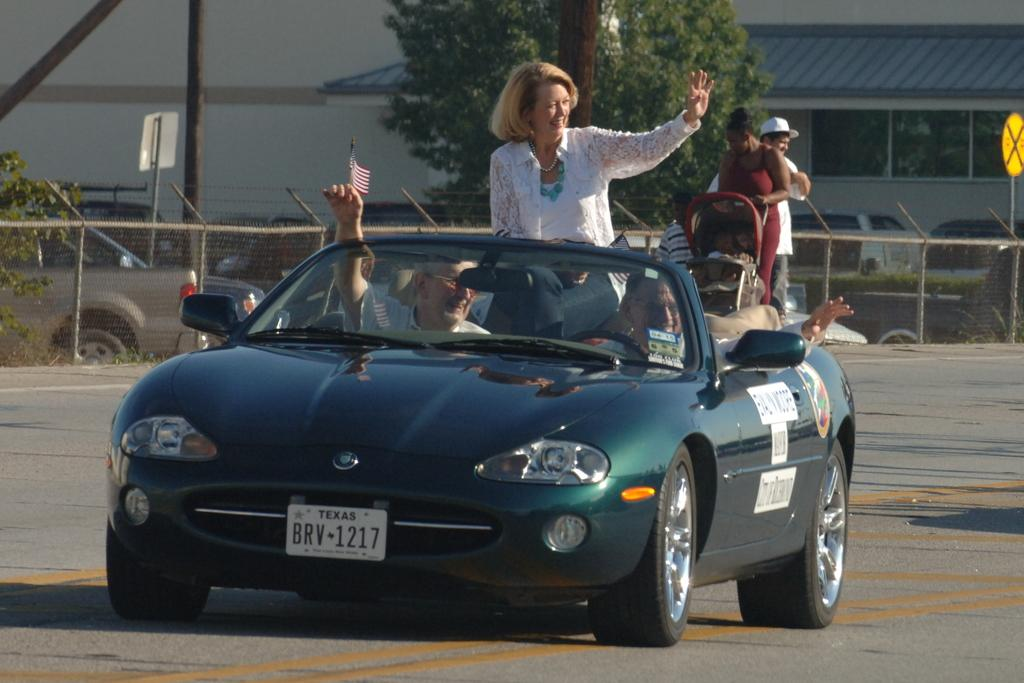What are the persons in the image doing? There are persons sitting in a car and standing in the image. What can be seen in the background of the image? There is a wall, a glass window, trees, vehicles on the road, and a fence in the background. What type of body is visible on the wall in the image? There is no body visible on the wall in the image. What holiday is being celebrated in the image? There is no indication of a holiday being celebrated in the image. 